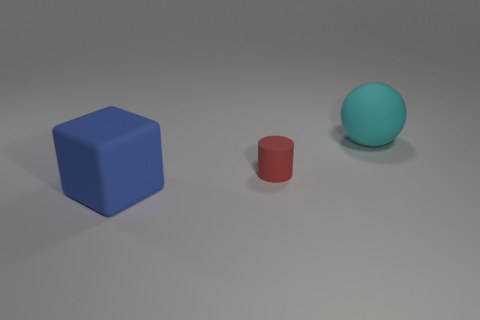Add 2 blue matte blocks. How many objects exist? 5 Subtract all cylinders. How many objects are left? 2 Subtract 0 blue cylinders. How many objects are left? 3 Subtract all red matte cylinders. Subtract all small cylinders. How many objects are left? 1 Add 2 large rubber blocks. How many large rubber blocks are left? 3 Add 3 small cylinders. How many small cylinders exist? 4 